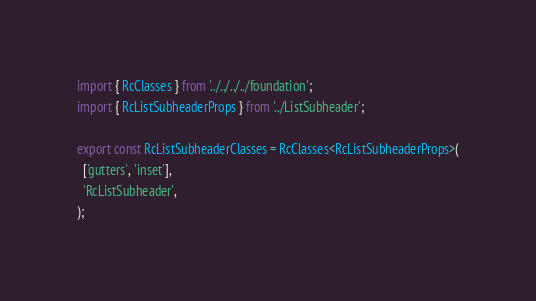<code> <loc_0><loc_0><loc_500><loc_500><_TypeScript_>import { RcClasses } from '../../../../foundation';
import { RcListSubheaderProps } from '../ListSubheader';

export const RcListSubheaderClasses = RcClasses<RcListSubheaderProps>(
  ['gutters', 'inset'],
  'RcListSubheader',
);
</code> 